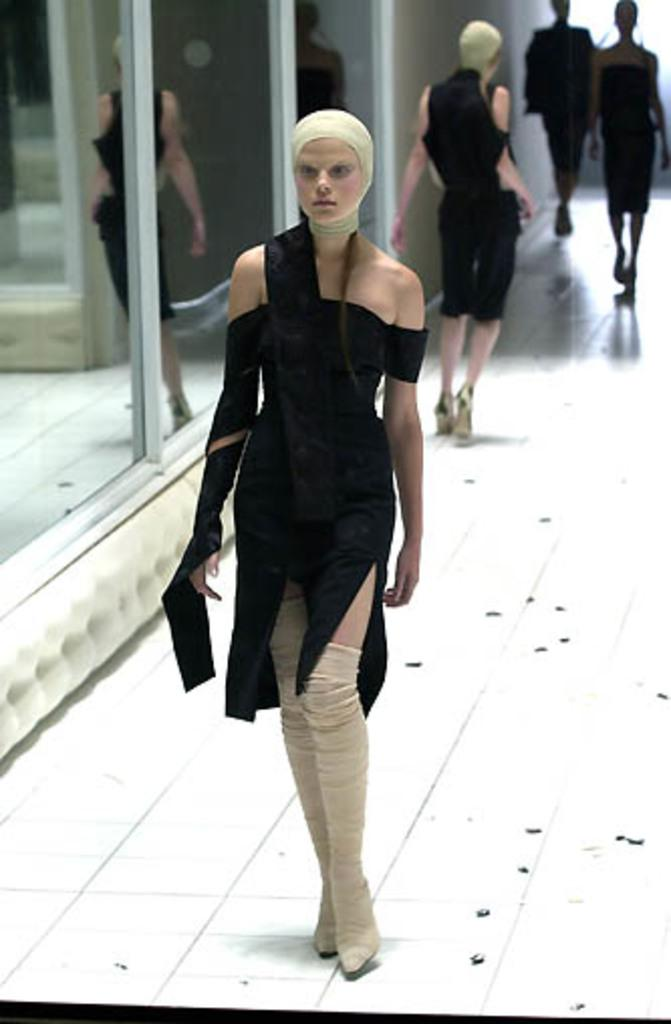Who is the main subject in the image? There is a woman in the image. What is the woman wearing? The woman is wearing a black dress. What is the color of the floor in the image? The floor is white. What are the other persons in the image doing? The other persons are walking on the white floor. What type of windows can be seen in the image? There are glass windows in the image. What is the background of the image made of? There is a wall in the image. What type of wax can be seen melting on the field in the image? There is no field or wax present in the image; it features a woman and other persons walking on a white floor with glass windows and a wall in the background. 